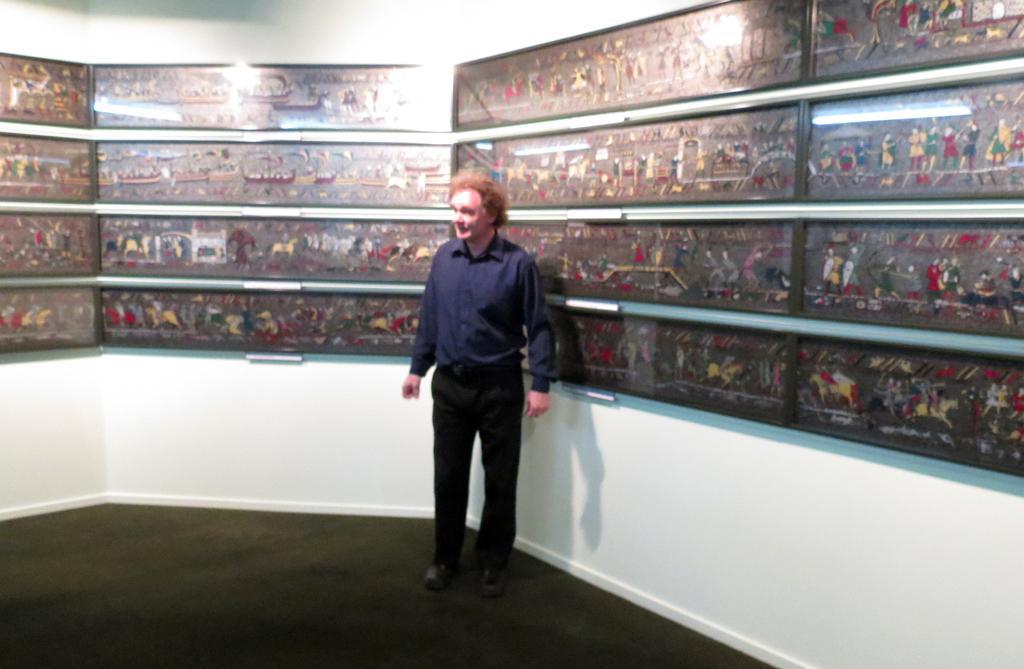Describe this image in one or two sentences. In this image I can see a person standing. He is wearing a purple color shirt and a black pant. In the back ground there is a cupboard with some paintings in side it. And also a wall can be seen. 